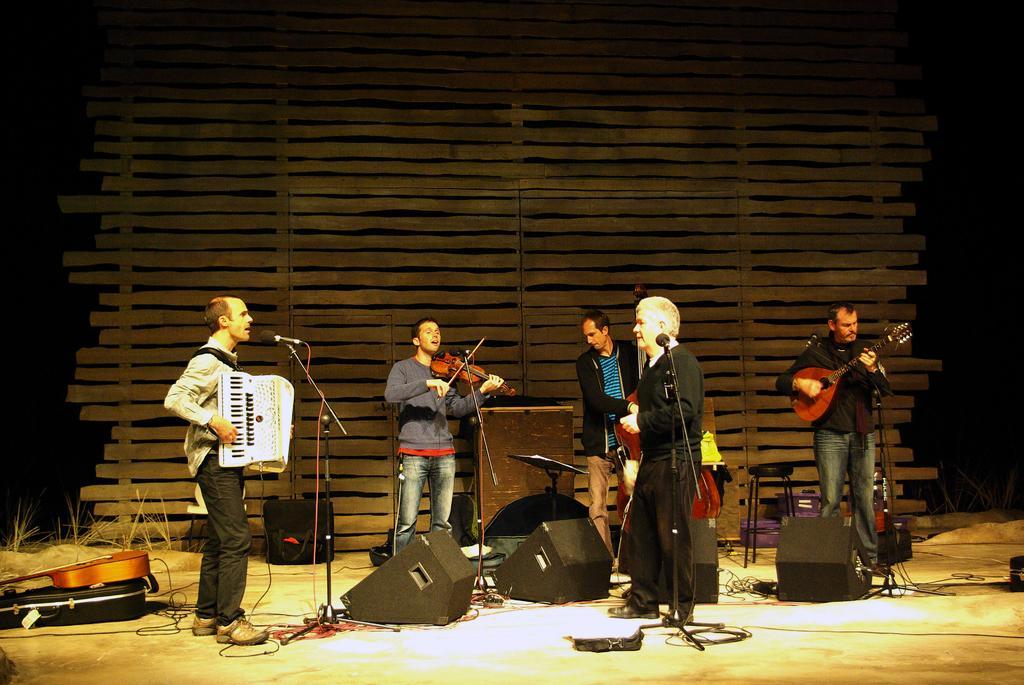Can you describe this image briefly? In this picture there are group of people on the stage, they are performing the music event, there are different music instrument on the stage like, guitars, harmonium, and piano and there is a mic in front of them and there are speakers around the stage. 